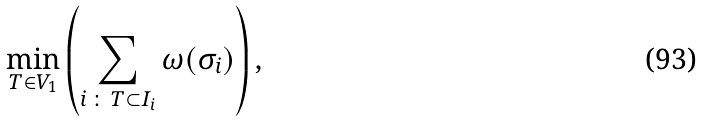<formula> <loc_0><loc_0><loc_500><loc_500>\min _ { T \in V _ { 1 } } \left ( \sum _ { i \, \colon \, T \subset I _ { i } } \omega ( \sigma _ { i } ) \right ) ,</formula> 